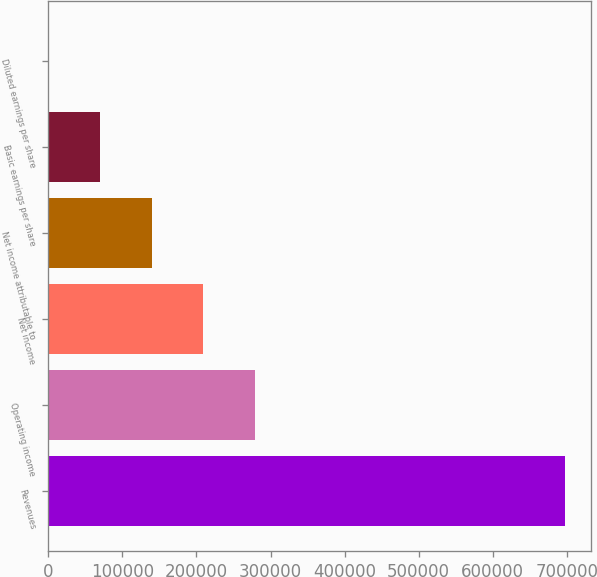Convert chart to OTSL. <chart><loc_0><loc_0><loc_500><loc_500><bar_chart><fcel>Revenues<fcel>Operating income<fcel>Net income<fcel>Net income attributable to<fcel>Basic earnings per share<fcel>Diluted earnings per share<nl><fcel>697291<fcel>278917<fcel>209188<fcel>139459<fcel>69730.1<fcel>1.1<nl></chart> 